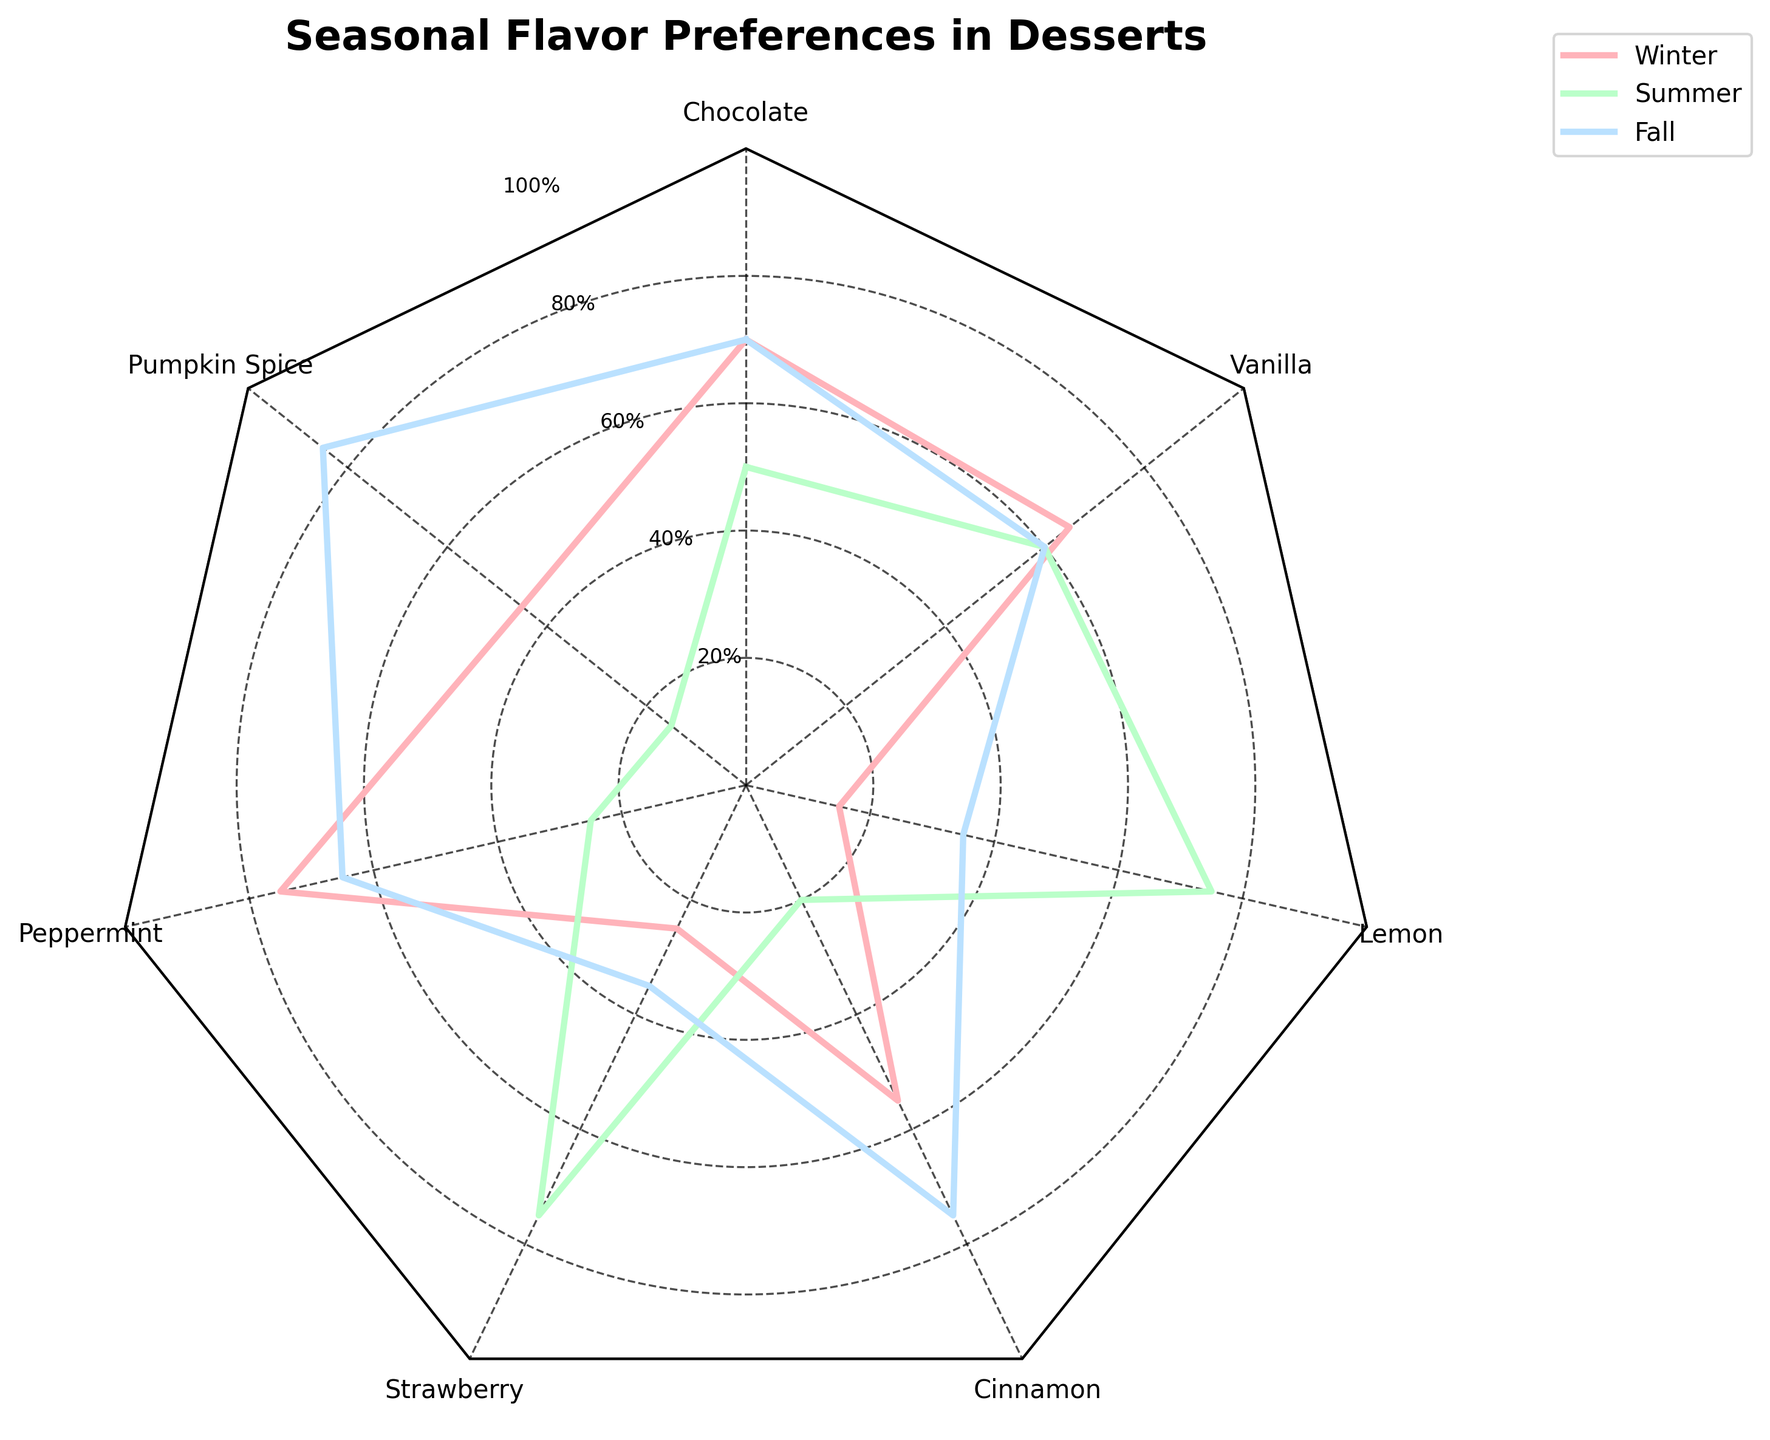What is the title of the radar chart? The title of the chart is located at the top and is usually in larger, bold font.
Answer: Seasonal Flavor Preferences in Desserts Which season has the highest preference for Chocolate in the age group of 26-40? The radar chart plots values in different segments, with 26-40 age groups shown as different colored lines. By following the color corresponding to the 26-40 age group, we find the peak for Chocolate in Winter.
Answer: Winter What is the lowest preference value for Strawberry, and in which season does it occur for the 26-40 age group? By following the line color corresponding to the 26-40 age group through all seasons for Strawberry, the lowest value is found in Fall.
Answer: Fall What flavor shows the highest increase in preference from Winter to Summer for the 26-40 age group? Comparing the changes in values for each flavor from Winter to Summer for the 26-40 age group, Peppermint shows the largest positive change from low to high.
Answer: Strawberry Which group shows relatively constant preference values across different seasons? By visually inspecting the lines for different groups across all seasons, Vanilla for the 26-40 age group shows relatively consistent values.
Answer: Vanilla Compare the preference for Lemon between Summer and Fall for the 26-40 age group. Which season has a higher preference? By observing the Lemon segment and comparing the values plotted for Summer and Fall under the 26-40 age group, Summer shows a higher preference.
Answer: Summer Which flavor shows the highest variability in preferences among different seasons for the 26-40 age group? By observing the range of values for each flavor across different seasons for the 26-40 age group, Lemon shows the highest variability, with values ranging significantly.
Answer: Lemon 